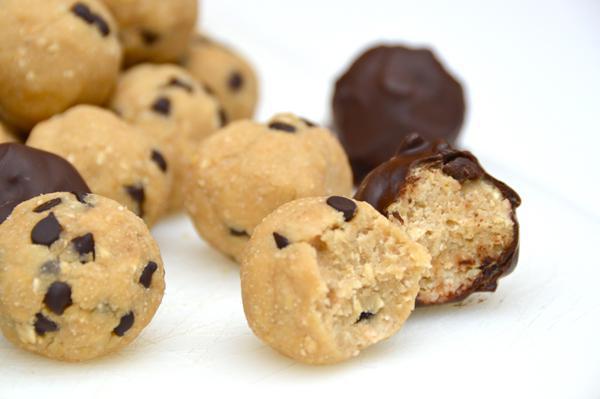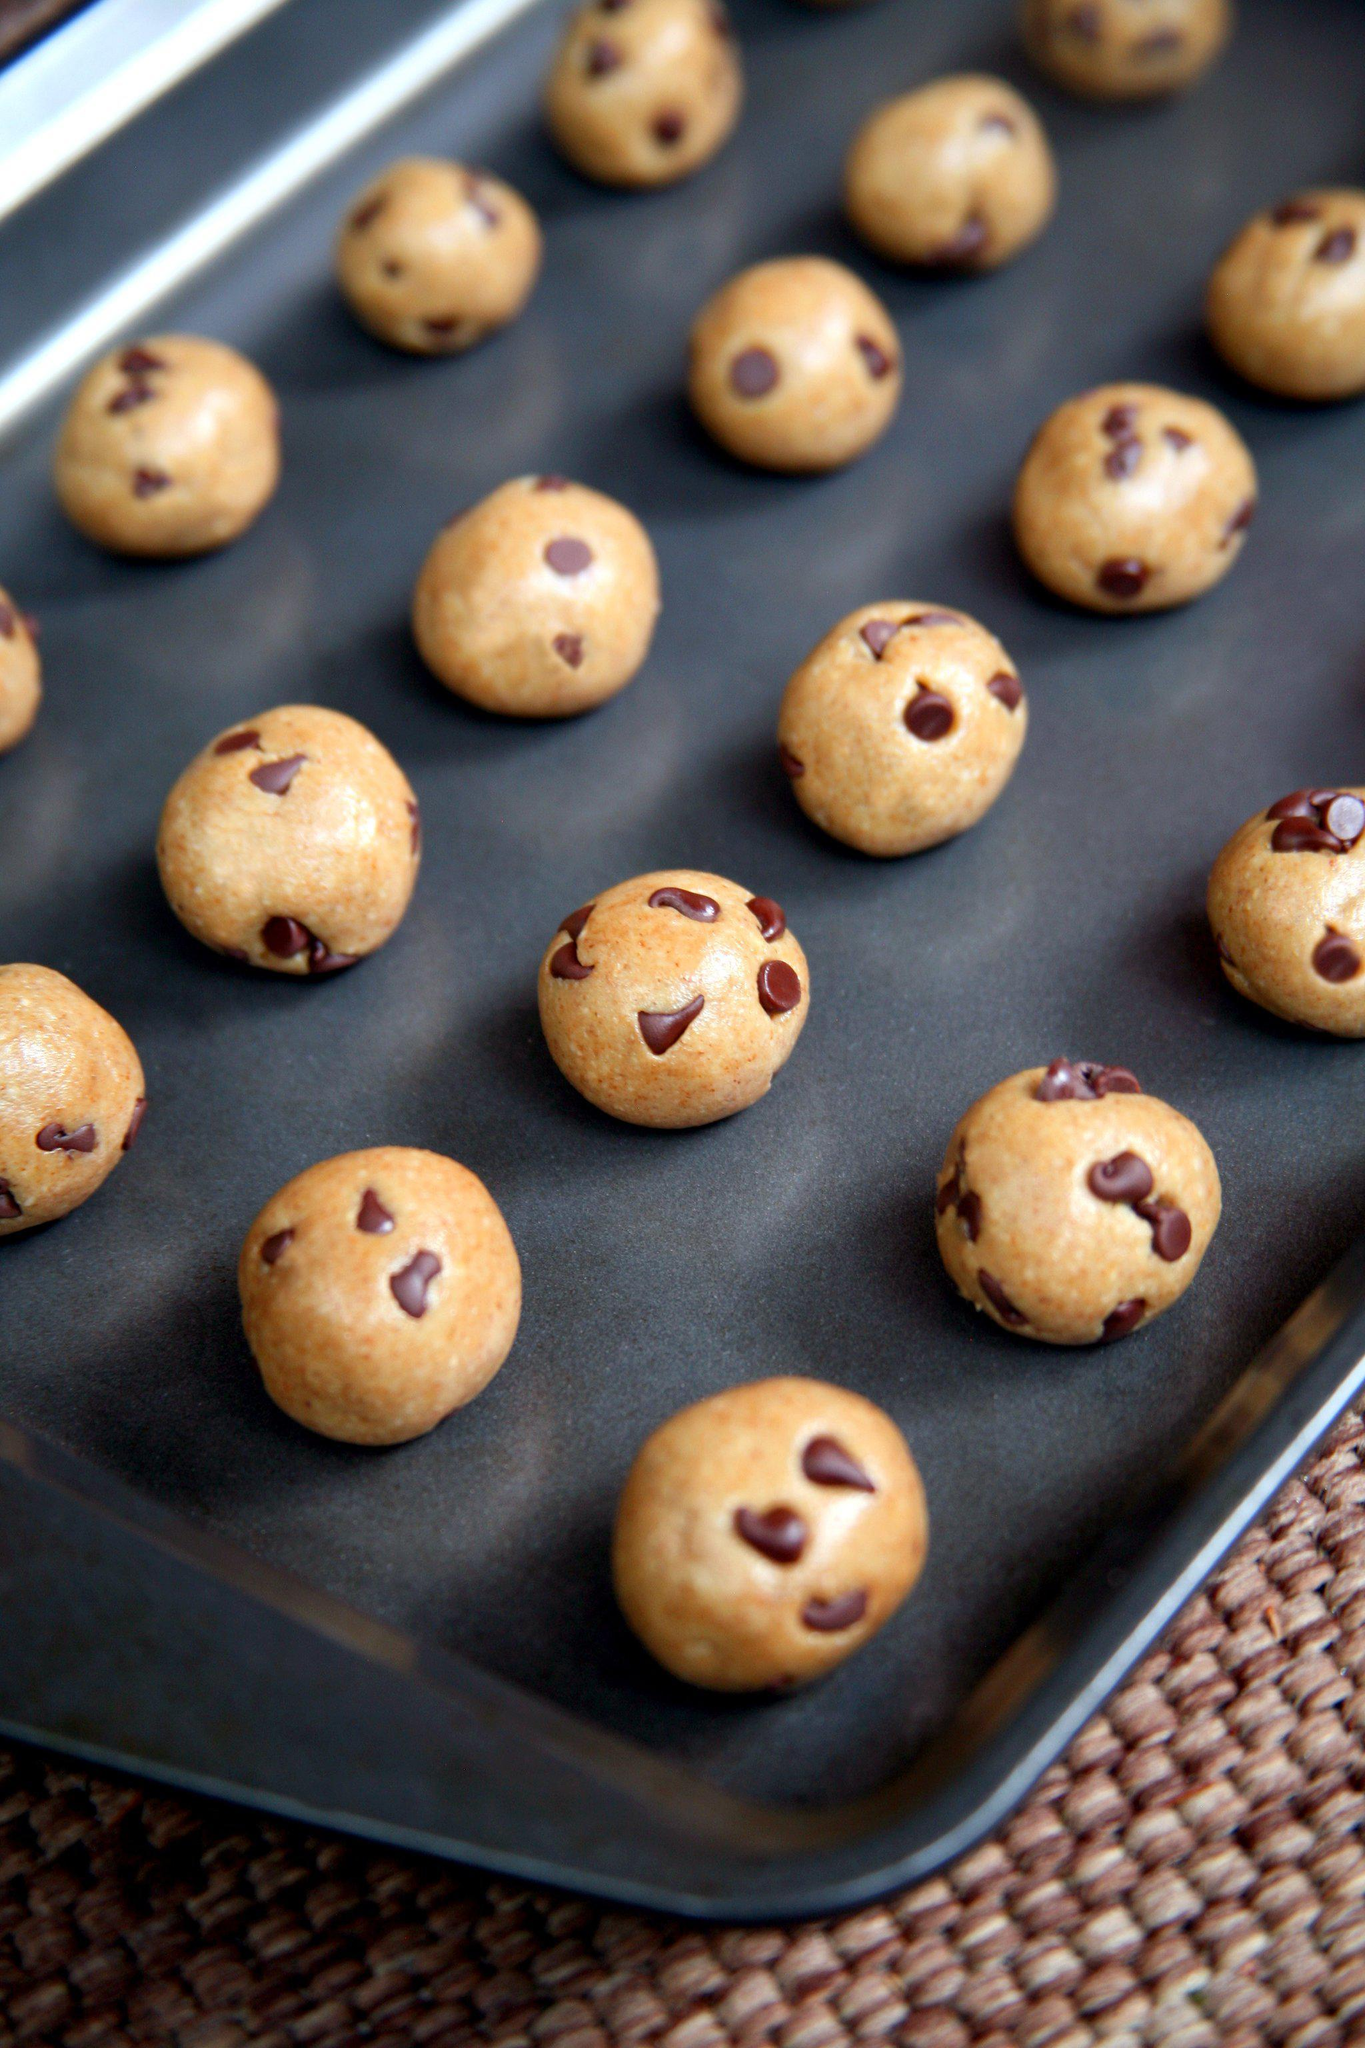The first image is the image on the left, the second image is the image on the right. For the images displayed, is the sentence "Every photo shows balls of dough inside of a bowl." factually correct? Answer yes or no. No. 